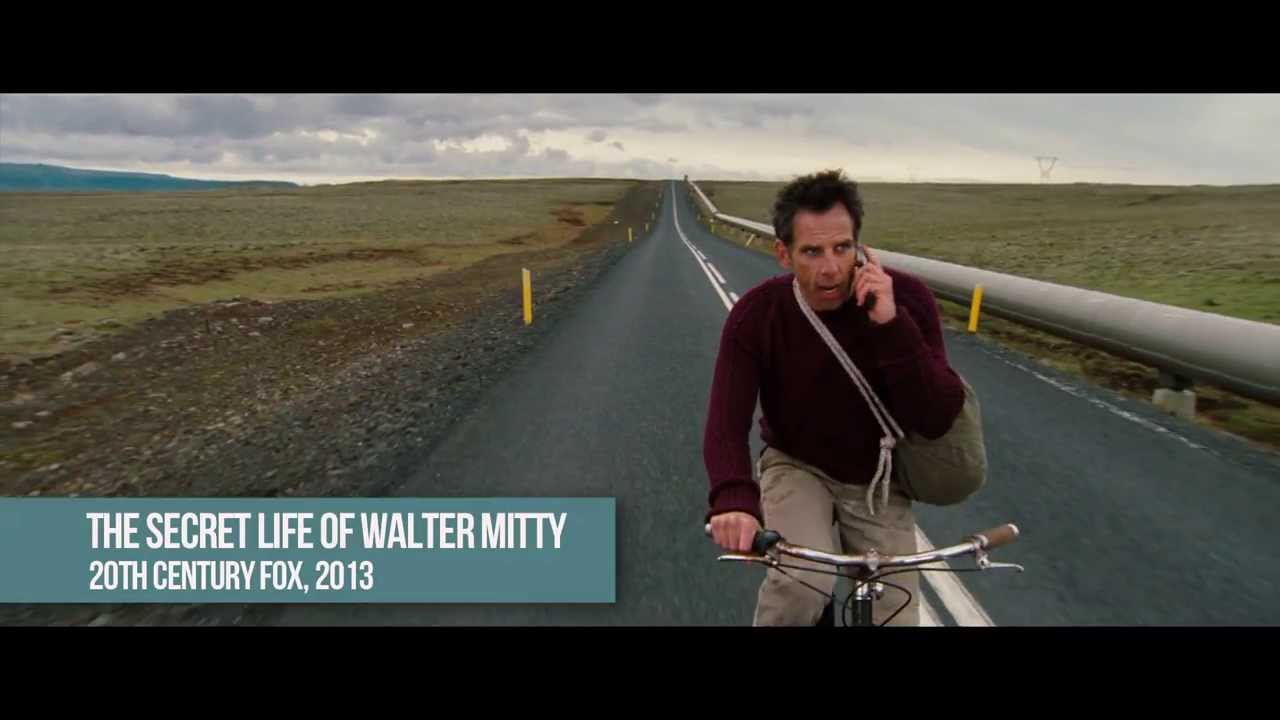Imagine a very creative question related to this image. If the man in the image could unlock portals with his bicycle, taking him to different dimensions with each turn of the wheel, what fantastical worlds might he encounter, and how would they aid or hinder his journey? Let's explore one of those dimensions where the sky is never dark! In this dimension, the sky is a constant swirl of brilliant hues—golden yellows, rosy pinks, and deep indigos—illuminated by a sun that never sets. The land is lush with bioluminescent plants that glow gently under the eternal twilight. The air is thick with the hum of otherworldly creatures and the scent of sweet nectar. Here, time flows differently, allowing the man to pedal without fatigue. Despite the glorious beauty, he faces challenges; the enchanted landscape shifts continually, often misleading travelers. He learns to read the subtle signs in the sky and follow hidden pathways marked by ancient symbols, guiding him closer to his destination. The bioluminescent flora provides nourishment and light, aiding his journey, while the landscape’s deceptive nature constantly tests his resolve and wits. 